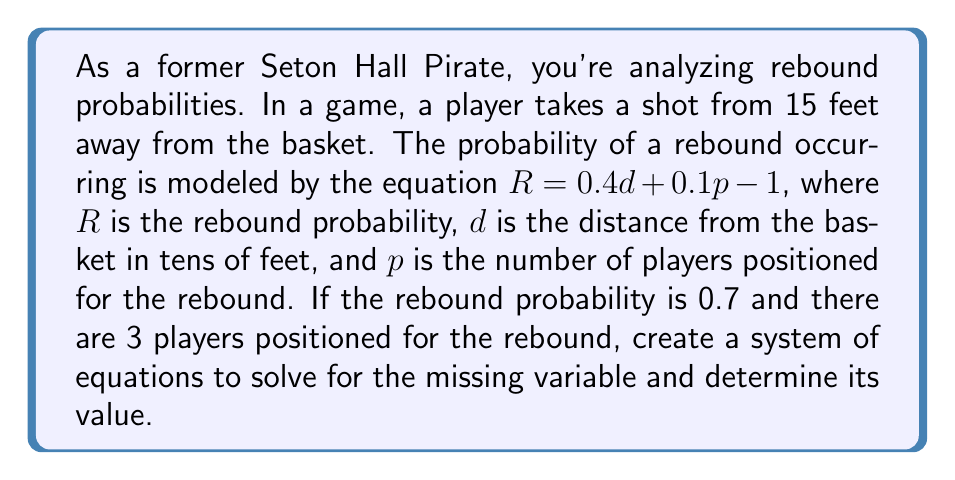Can you answer this question? Let's approach this step-by-step:

1) We're given the equation for rebound probability:
   $$R = 0.4d + 0.1p - 1$$

2) We know the following:
   - The shot distance is 15 feet, so $d = 1.5$ (since $d$ is in tens of feet)
   - The rebound probability $R = 0.7$
   - The number of players positioned for the rebound $p = 3$

3) Let's substitute these known values into the equation:
   $$0.7 = 0.4(1.5) + 0.1p - 1$$

4) Simplify:
   $$0.7 = 0.6 + 0.1p - 1$$
   $$0.7 = 0.1p - 0.4$$

5) Add 0.4 to both sides:
   $$1.1 = 0.1p$$

6) Divide both sides by 0.1:
   $$11 = p$$

Therefore, the system of equations is:
$$\begin{cases}
R = 0.4d + 0.1p - 1 \\
0.7 = 0.4(1.5) + 0.1p - 1
\end{cases}$$

And solving this system gives us $p = 11$.
Answer: $p = 11$ players 